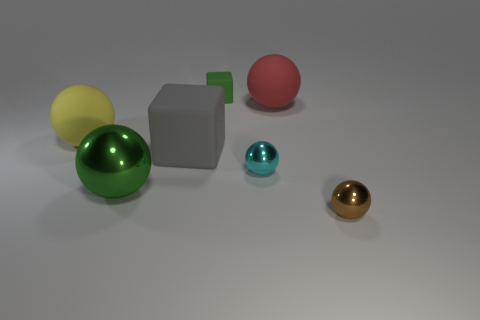There is a tiny rubber object that is the same color as the large shiny object; what shape is it?
Provide a succinct answer. Cube. How many other things have the same size as the green matte thing?
Your answer should be very brief. 2. The large matte object to the left of the green metal thing has what shape?
Your response must be concise. Sphere. Are there fewer big red cylinders than large gray rubber objects?
Ensure brevity in your answer.  Yes. Are there any other things that have the same color as the big shiny object?
Offer a terse response. Yes. There is a matte thing on the right side of the tiny cyan thing; how big is it?
Ensure brevity in your answer.  Large. Are there more big gray matte cubes than large red shiny spheres?
Your answer should be very brief. Yes. What is the large block made of?
Offer a terse response. Rubber. How many other objects are there of the same material as the green ball?
Provide a short and direct response. 2. How many tiny purple cylinders are there?
Your answer should be compact. 0. 